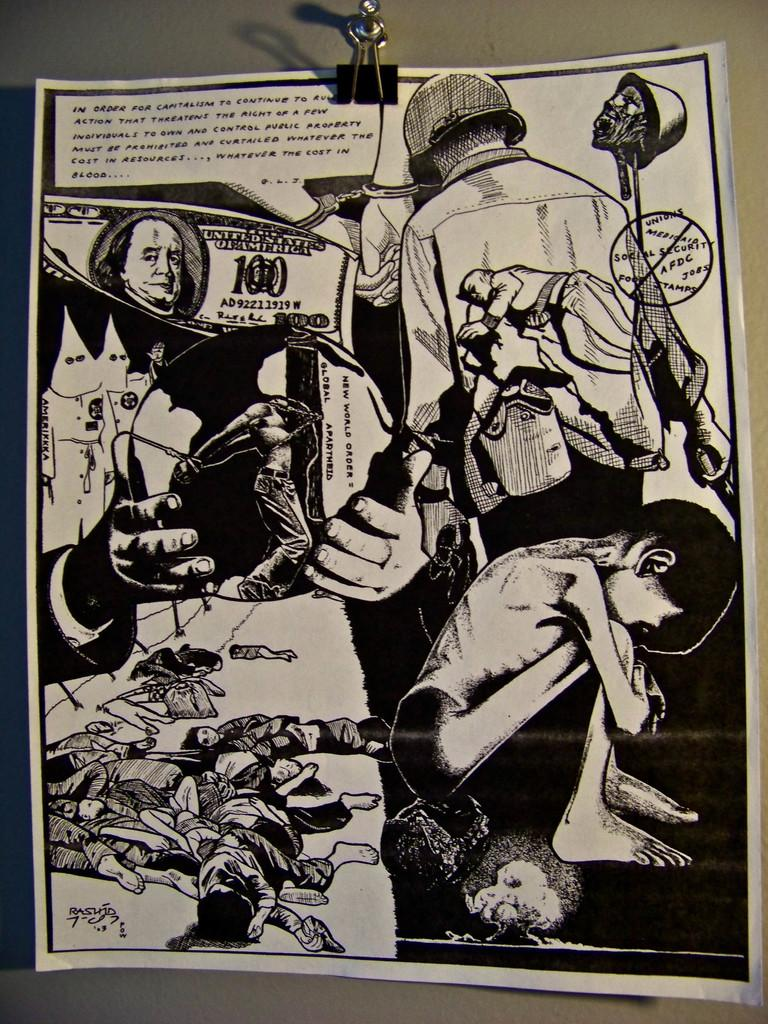Provide a one-sentence caption for the provided image. A black and white illustrated page includes images of suffering and gore along with a 100 dollar Unites States bill. 